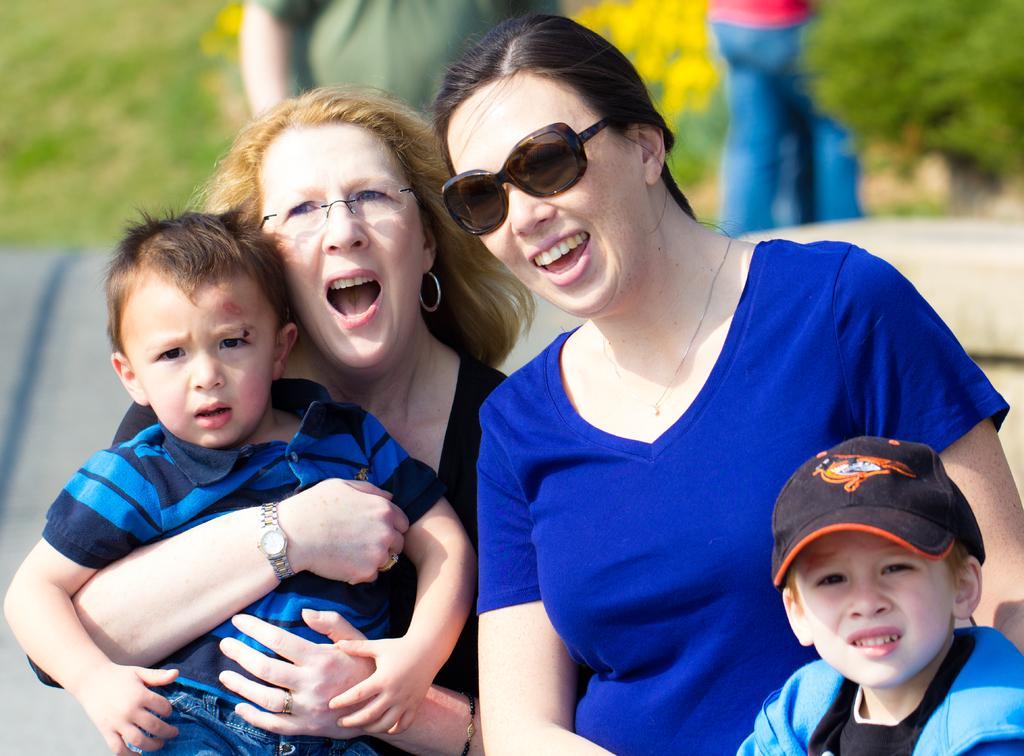In one or two sentences, can you explain what this image depicts? In the picture there are four people in the front, two women and two kids the first woman is holding a boy with her arms and both of the women are smiling and excited, behind them there are two other people and the background is blurry. 